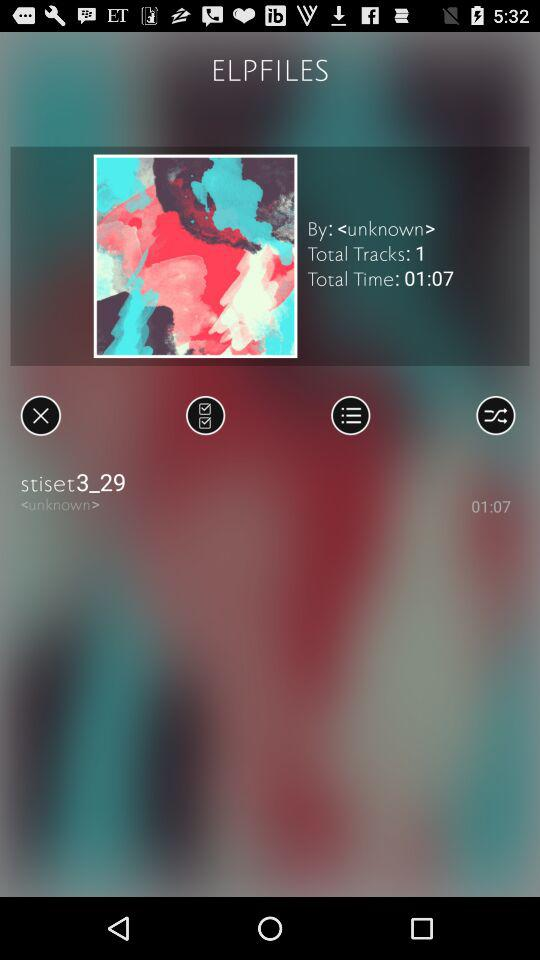Who is the singer of the album? The singer is unknown. 